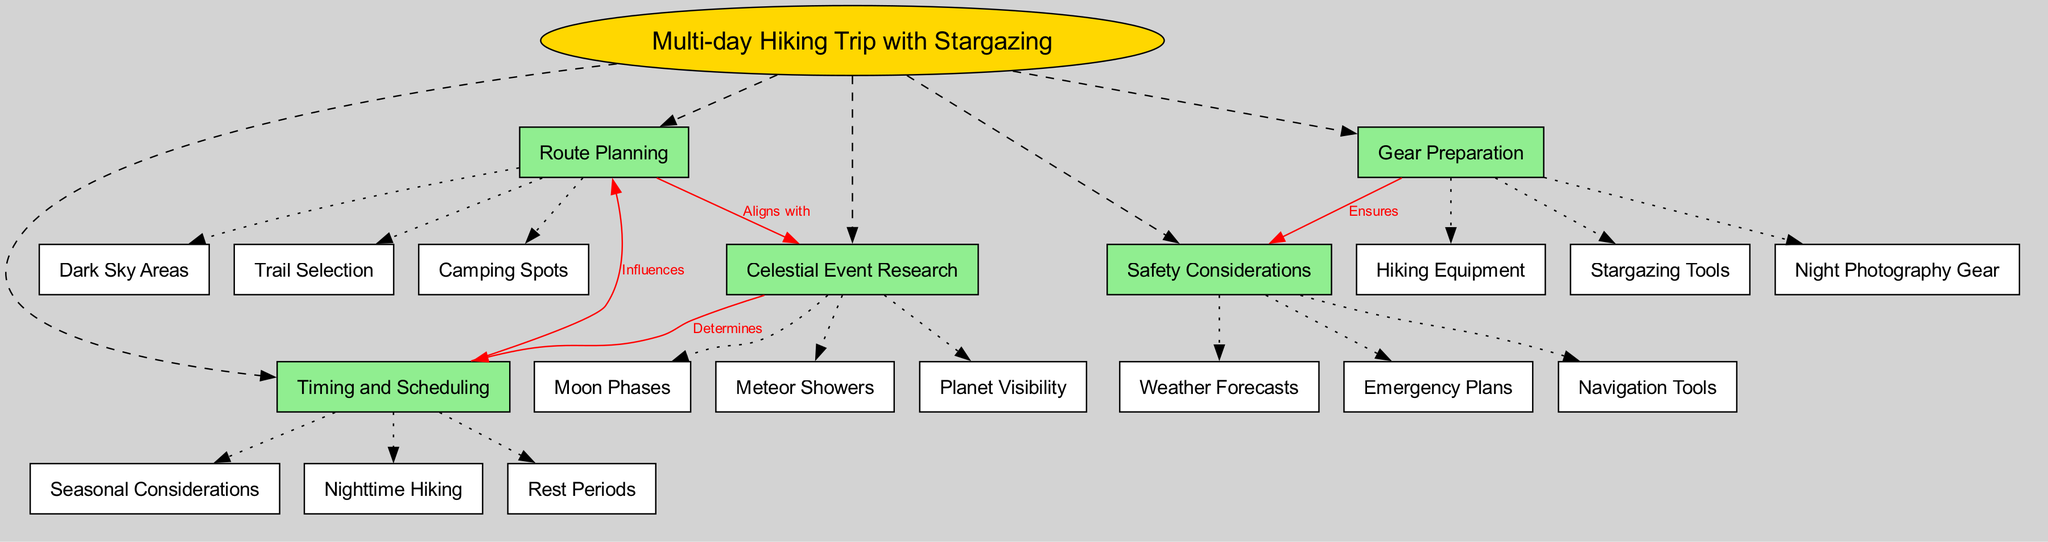What is the central concept of the diagram? The central concept is explicitly stated in the diagram as "Multi-day Hiking Trip with Stargazing." It’s the focal point that connects to all other nodes.
Answer: Multi-day Hiking Trip with Stargazing How many main nodes are present in the diagram? The diagram lists five main nodes: Route Planning, Gear Preparation, Celestial Event Research, Timing and Scheduling, and Safety Considerations. Counting these gives us a total of five main nodes.
Answer: 5 Which sub-node is directly connected to "Gear Preparation"? The sub-nodes listed under "Gear Preparation" include Hiking Equipment, Stargazing Tools, and Night Photography Gear. Thus, each of these three sub-nodes can be directly connected to "Gear Preparation."
Answer: Hiking Equipment What relationship is shown between "Route Planning" and "Celestial Event Research"? The diagram clearly labels the connection between "Route Planning" and "Celestial Event Research" as "Aligns with." This indicates a directional relationship implicating alignment of these two aspects when planning the trip.
Answer: Aligns with Which node influences "Route Planning"? The diagram indicates that "Timing and Scheduling" has a connection to "Route Planning" with the label "Influences." This shows that considerations regarding timing and scheduling impact decisions made during the route planning stage.
Answer: Timing and Scheduling How do "Celestial Event Research" and "Timing and Scheduling" relate? The diagram connects "Celestial Event Research" to "Timing and Scheduling" with a label that states "Determines." This suggests that the research into celestial events impacts how timing and scheduling are approached during the trip planning.
Answer: Determines What does "Gear Preparation" ensure in the context of the diagram? The connection established in the diagram states that "Gear Preparation" ensures "Safety Considerations." This indicates that adequate preparation of the necessary gear promotes safety during the hiking trip.
Answer: Safety Considerations What are the types of celestial events included in the research sub-nodes? The sub-nodes under "Celestial Event Research" include Moon Phases, Meteor Showers, and Planet Visibility. These types of celestial events are crucial for stargazing opportunities during the hiking trip.
Answer: Moon Phases, Meteor Showers, Planet Visibility How many safety considerations are listed in the diagram? The diagram lists three safety considerations: Weather Forecasts, Emergency Plans, and Navigation Tools. The inclusion of these three items means that there are three distinct considerations for safety listed in the diagram.
Answer: 3 